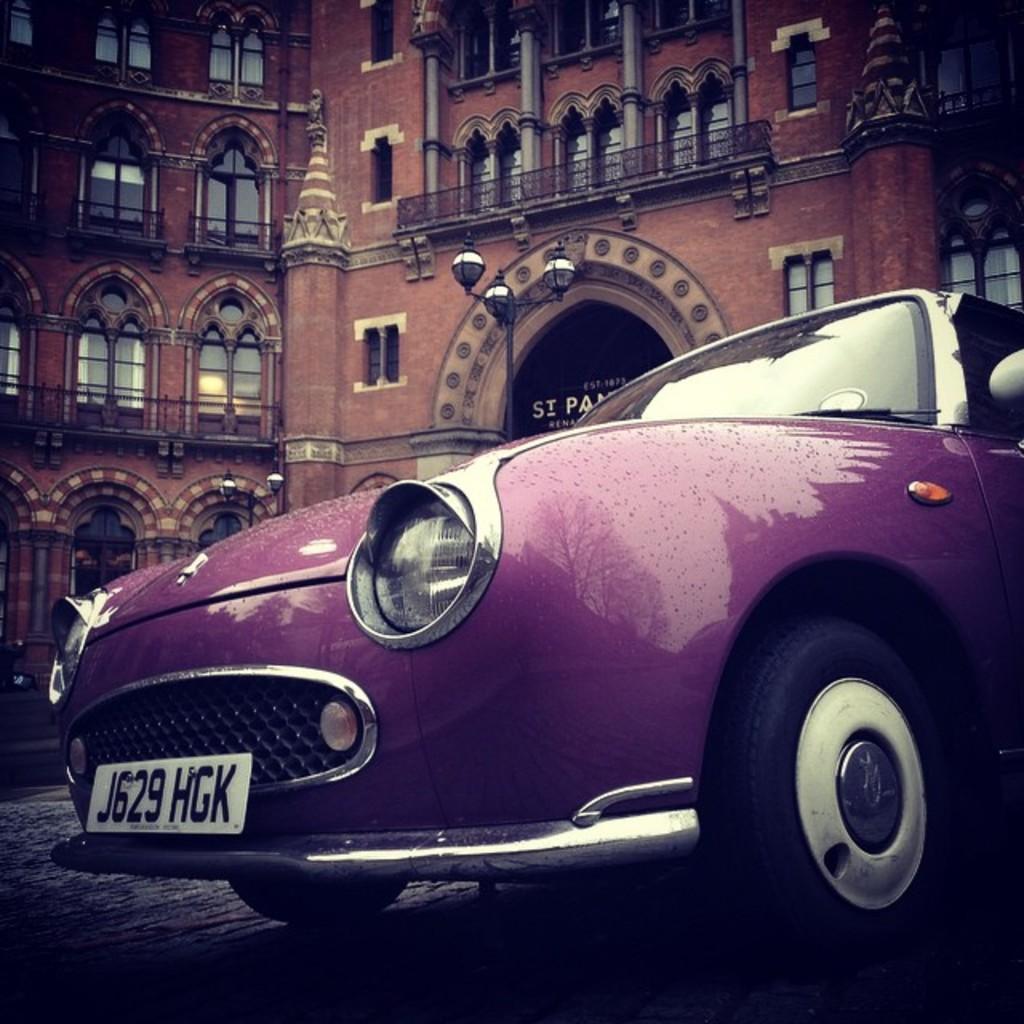Could you give a brief overview of what you see in this image? This is a car, which is violet in color. I can see the wheel, bumper, number plate, headlights and glasses, which are attached to the car. I can see the reflection of the tree and buildings on the car. This looks like a street light. This is a building with windows and pillars. 